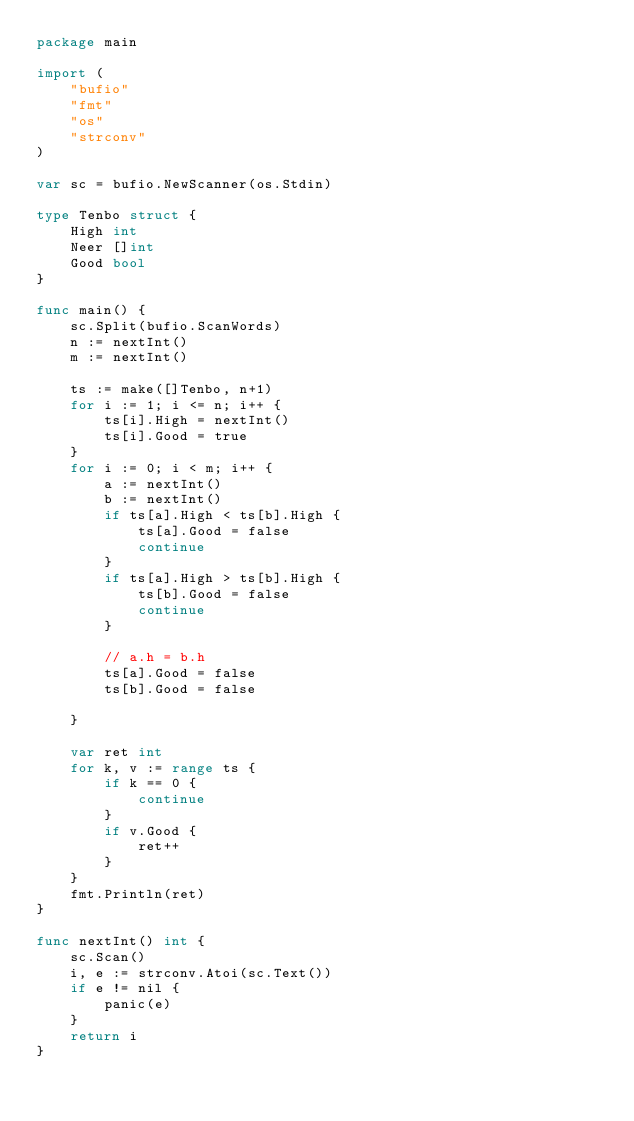Convert code to text. <code><loc_0><loc_0><loc_500><loc_500><_Go_>package main

import (
	"bufio"
	"fmt"
	"os"
	"strconv"
)

var sc = bufio.NewScanner(os.Stdin)

type Tenbo struct {
	High int
	Neer []int
	Good bool
}

func main() {
	sc.Split(bufio.ScanWords)
	n := nextInt()
	m := nextInt()

	ts := make([]Tenbo, n+1)
	for i := 1; i <= n; i++ {
		ts[i].High = nextInt()
		ts[i].Good = true
	}
	for i := 0; i < m; i++ {
		a := nextInt()
		b := nextInt()
		if ts[a].High < ts[b].High {
			ts[a].Good = false
			continue
		}
		if ts[a].High > ts[b].High {
			ts[b].Good = false
			continue
		}

		// a.h = b.h
		ts[a].Good = false
		ts[b].Good = false

	}

	var ret int
	for k, v := range ts {
		if k == 0 {
			continue
		}
		if v.Good {
			ret++
		}
	}
	fmt.Println(ret)
}

func nextInt() int {
	sc.Scan()
	i, e := strconv.Atoi(sc.Text())
	if e != nil {
		panic(e)
	}
	return i
}
</code> 